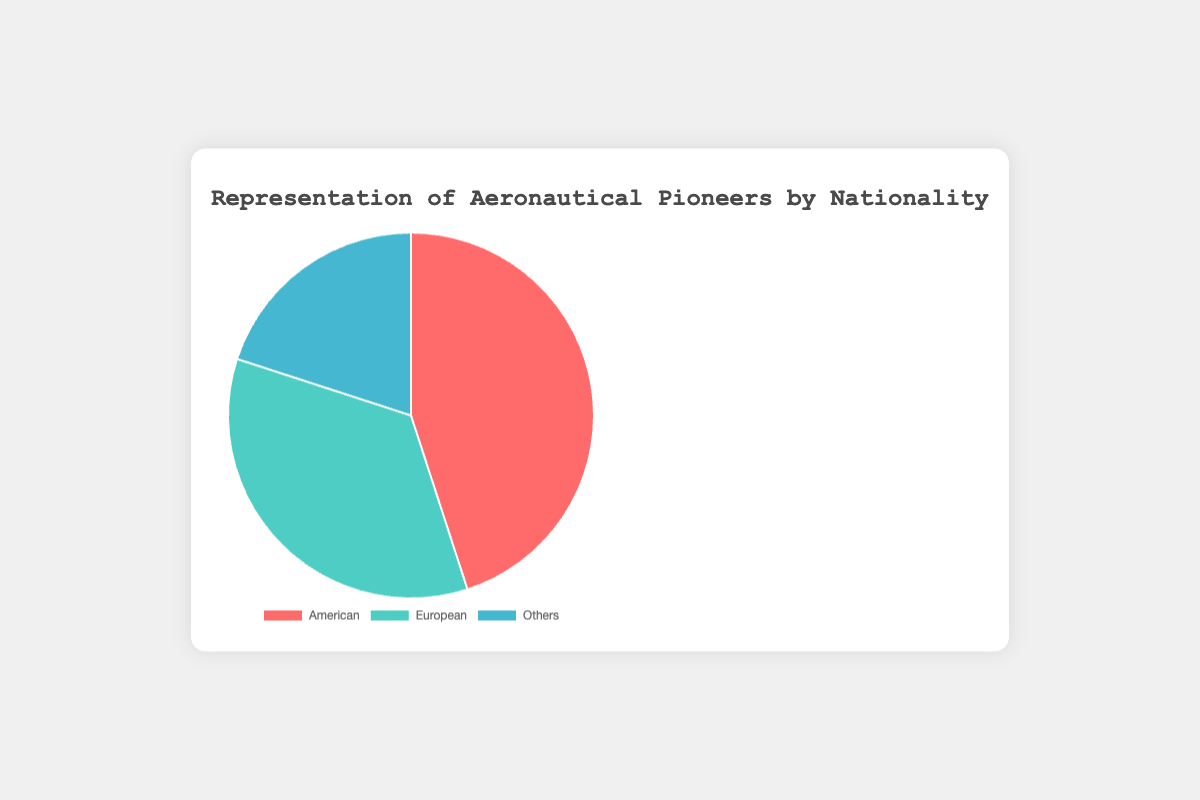Which nationality has the highest representation among aeronautical pioneers? By looking at the sections of the pie chart, the American section is the largest.
Answer: American What is the combined percentage of American and European aeronautical pioneers? The American pioneers make up 45% and the European pioneers make up 35%. Summing these percentages gives 45% + 35% = 80%.
Answer: 80% What is the difference in representation between American and European aeronautical pioneers? The American pioneers account for 45% while the European pioneers account for 35%. The difference in their representation is 45% - 35% = 10%.
Answer: 10% Which group has the smallest representation, and what is its percentage? By observing the pie chart, the 'Others' section is the smallest. The 'Others' group accounts for 20%.
Answer: Others, 20% How many times larger is the representation of American pioneers compared to the representation of 'Others'? The American pioneers account for 45%, and 'Others' account for 20%. The ratio of American to 'Others' is 45% / 20% = 2.25.
Answer: 2.25 If the representation of 'Others' increased by 10%, what would be the new percentage of 'Others'? The current representation of 'Others' is 20%. An increase of 10% results in 20% + 10% = 30%.
Answer: 30% What fraction of the total representation is made up by the European pioneers? The European pioneers have a representation of 35%. The fraction form of this would be 35/100. Thus, it simplifies to 7/20.
Answer: 7/20 What are the colors representing American, European, and 'Others' groups? From the visual observation, American is represented by a red section, European by a green section, and 'Others' by a blue section.
Answer: American: red, European: green, Others: blue 